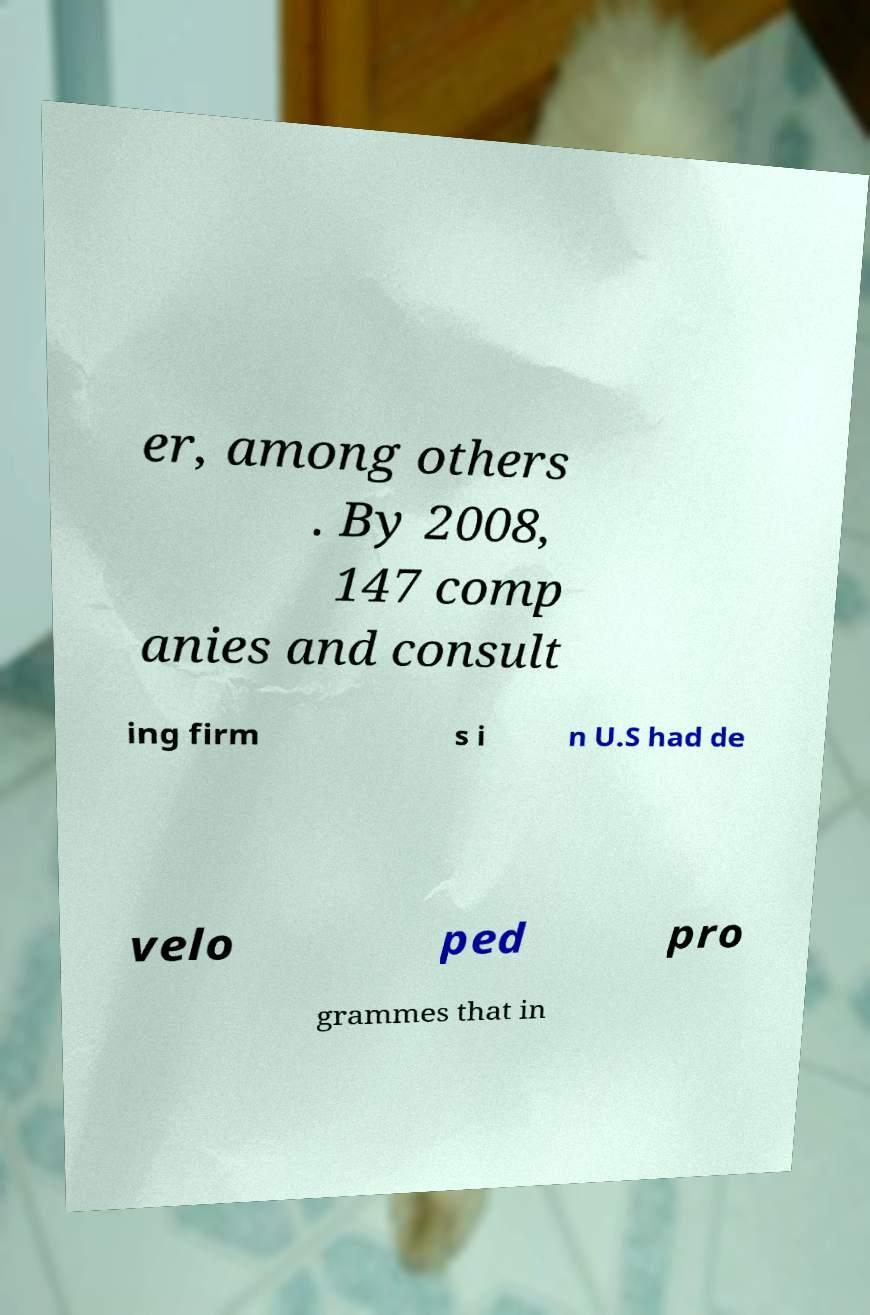What messages or text are displayed in this image? I need them in a readable, typed format. er, among others . By 2008, 147 comp anies and consult ing firm s i n U.S had de velo ped pro grammes that in 